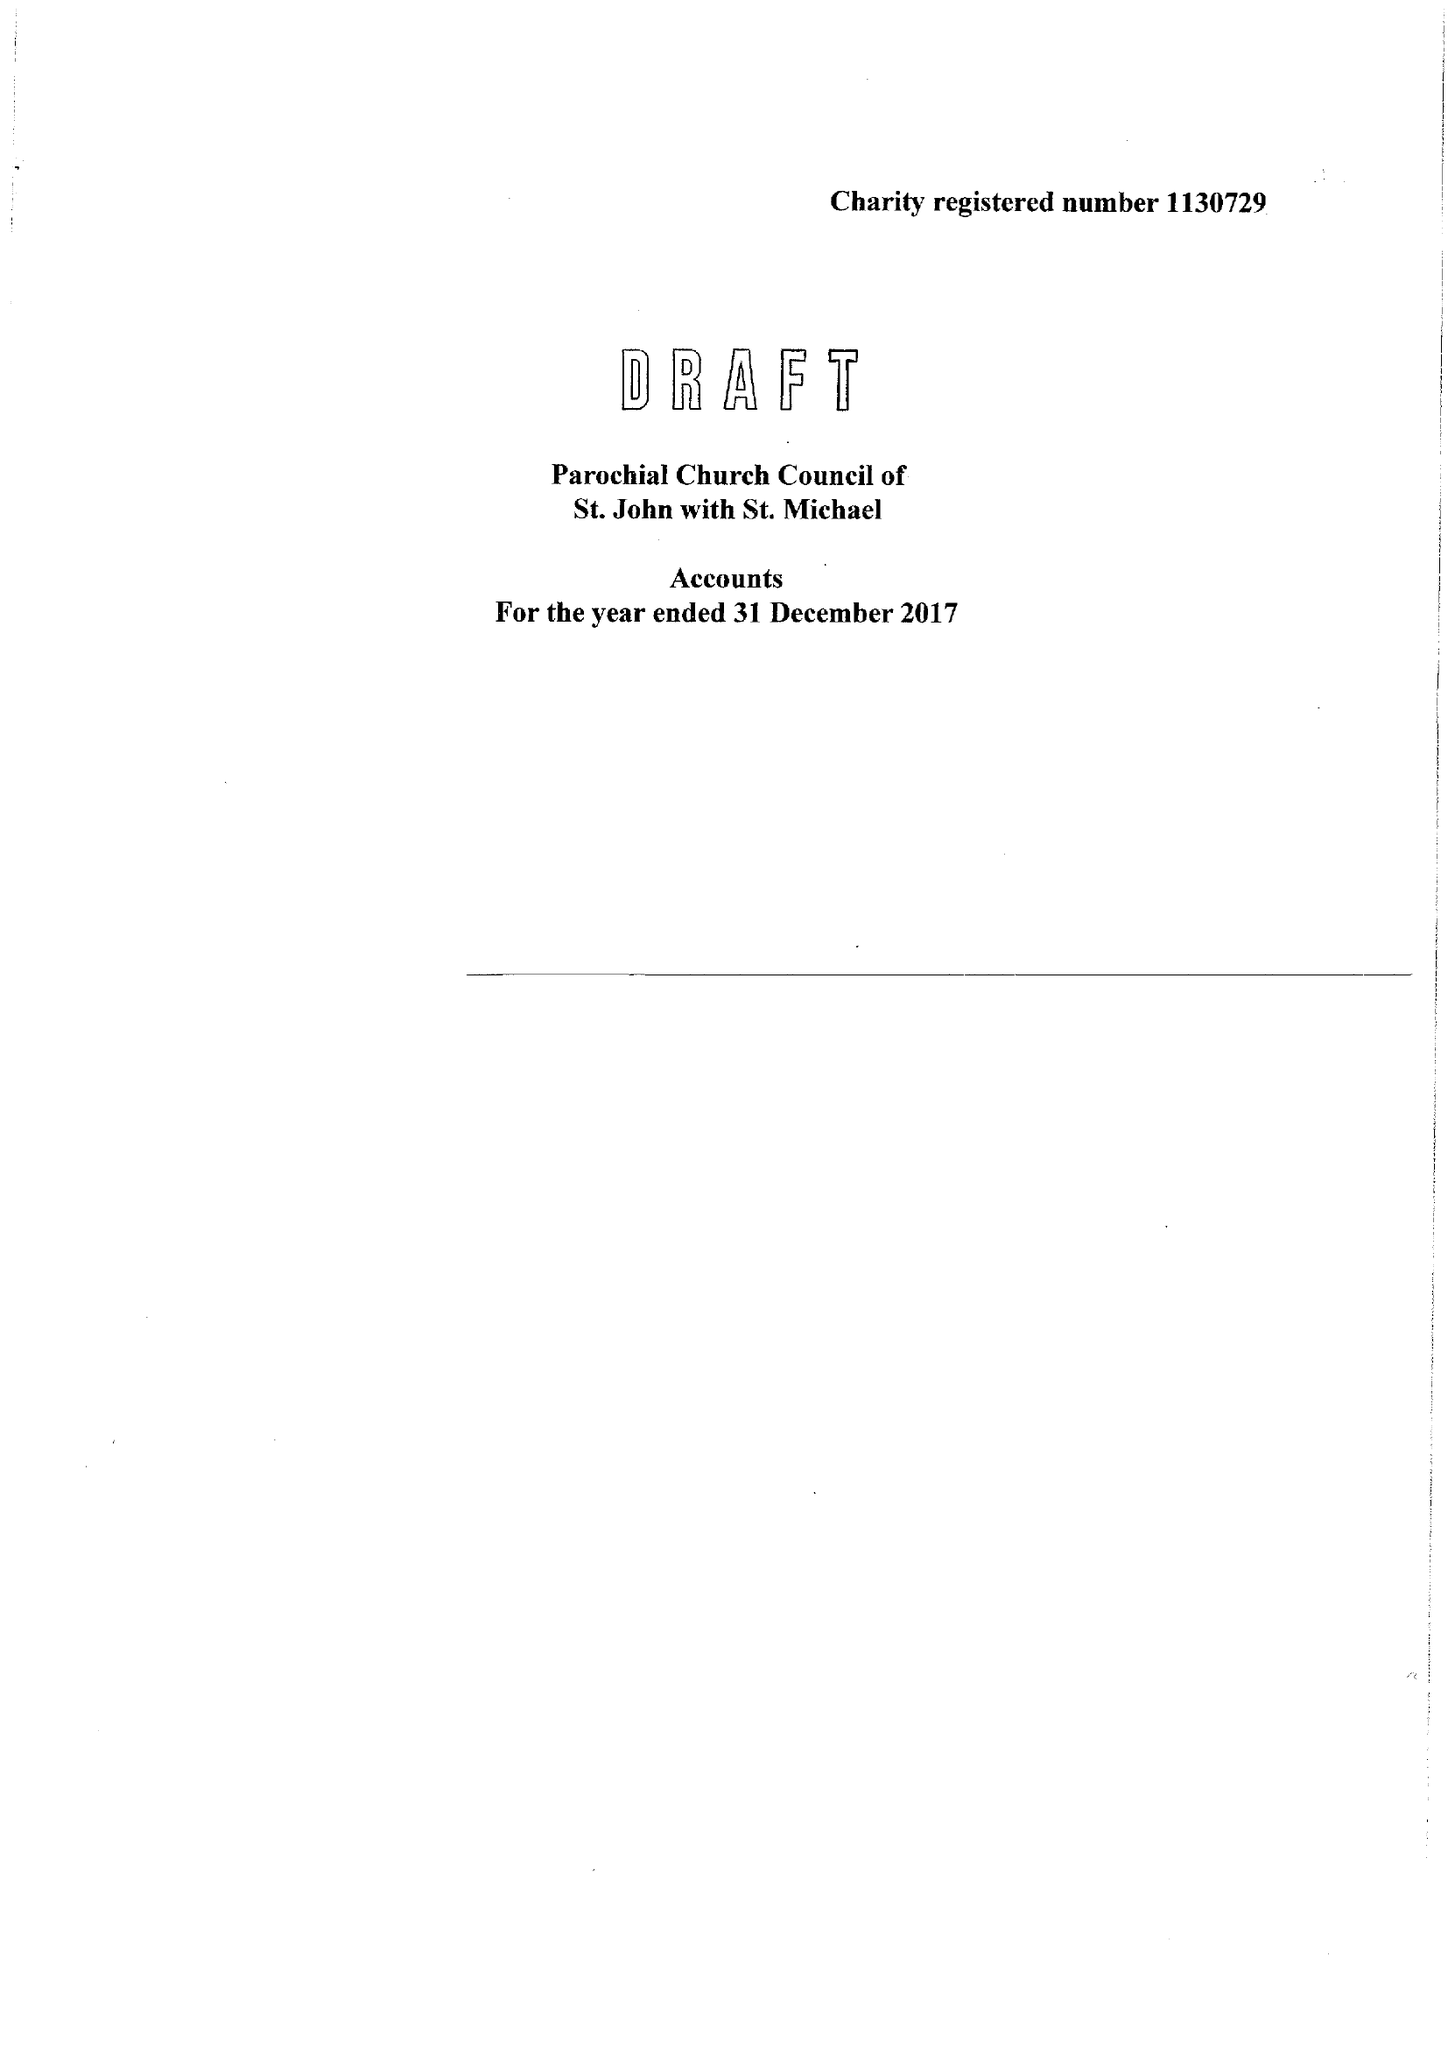What is the value for the charity_name?
Answer the question using a single word or phrase. Parochial Church Council Of St. John With St. Michael 